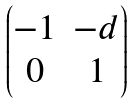<formula> <loc_0><loc_0><loc_500><loc_500>\begin{pmatrix} - 1 & - d \\ 0 & 1 \\ \end{pmatrix}</formula> 